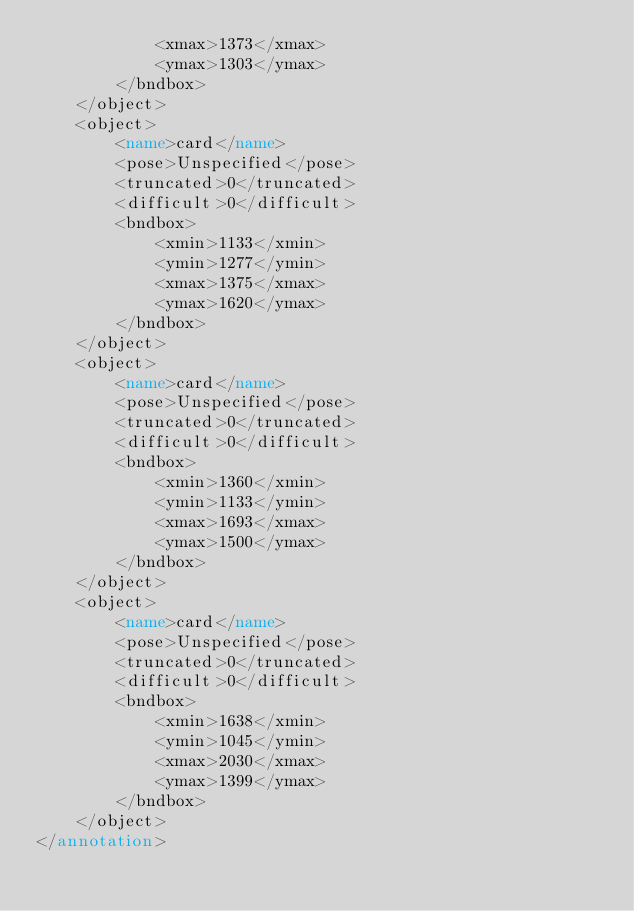<code> <loc_0><loc_0><loc_500><loc_500><_XML_>			<xmax>1373</xmax>
			<ymax>1303</ymax>
		</bndbox>
	</object>
	<object>
		<name>card</name>
		<pose>Unspecified</pose>
		<truncated>0</truncated>
		<difficult>0</difficult>
		<bndbox>
			<xmin>1133</xmin>
			<ymin>1277</ymin>
			<xmax>1375</xmax>
			<ymax>1620</ymax>
		</bndbox>
	</object>
	<object>
		<name>card</name>
		<pose>Unspecified</pose>
		<truncated>0</truncated>
		<difficult>0</difficult>
		<bndbox>
			<xmin>1360</xmin>
			<ymin>1133</ymin>
			<xmax>1693</xmax>
			<ymax>1500</ymax>
		</bndbox>
	</object>
	<object>
		<name>card</name>
		<pose>Unspecified</pose>
		<truncated>0</truncated>
		<difficult>0</difficult>
		<bndbox>
			<xmin>1638</xmin>
			<ymin>1045</ymin>
			<xmax>2030</xmax>
			<ymax>1399</ymax>
		</bndbox>
	</object>
</annotation>
</code> 